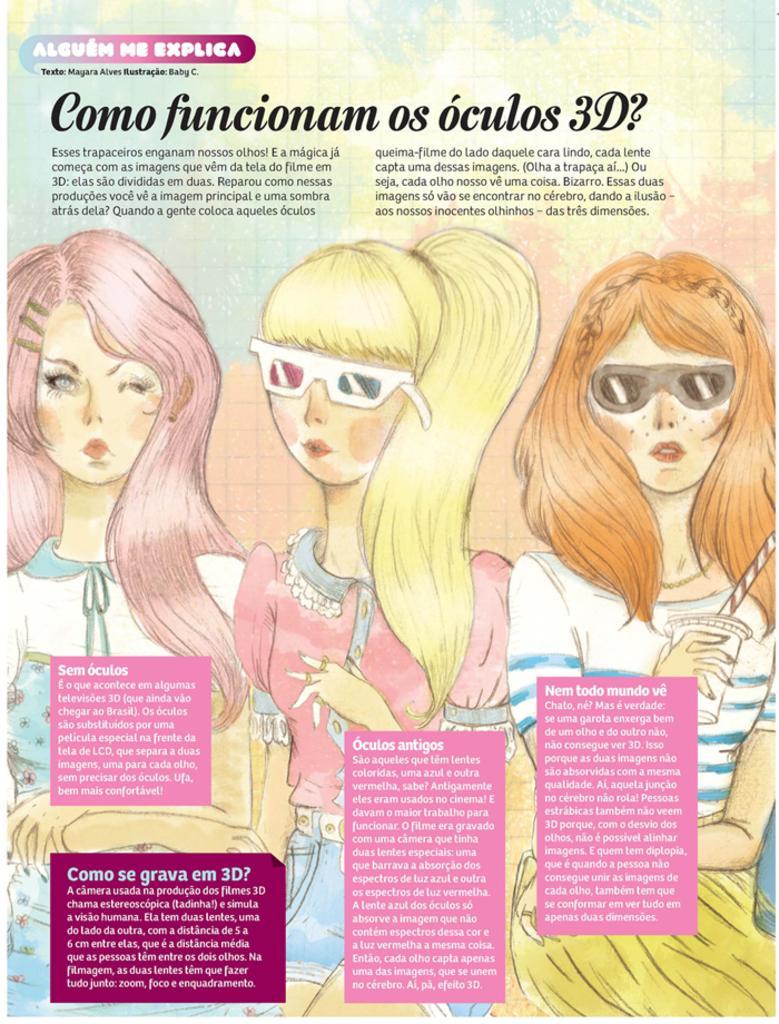In one or two sentences, can you explain what this image depicts? In this image we can see the picture of three girls standing. In that a girl is holding a glass with a straw. We can also see some text on this image. 